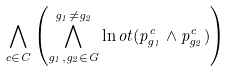<formula> <loc_0><loc_0><loc_500><loc_500>\bigwedge _ { c \in C } \left ( \bigwedge _ { g _ { 1 } , g _ { 2 } \in G } ^ { g _ { 1 } \neq g _ { 2 } } \ln o t ( p _ { g _ { 1 } } ^ { c } \land p _ { g _ { 2 } } ^ { c } ) \right )</formula> 